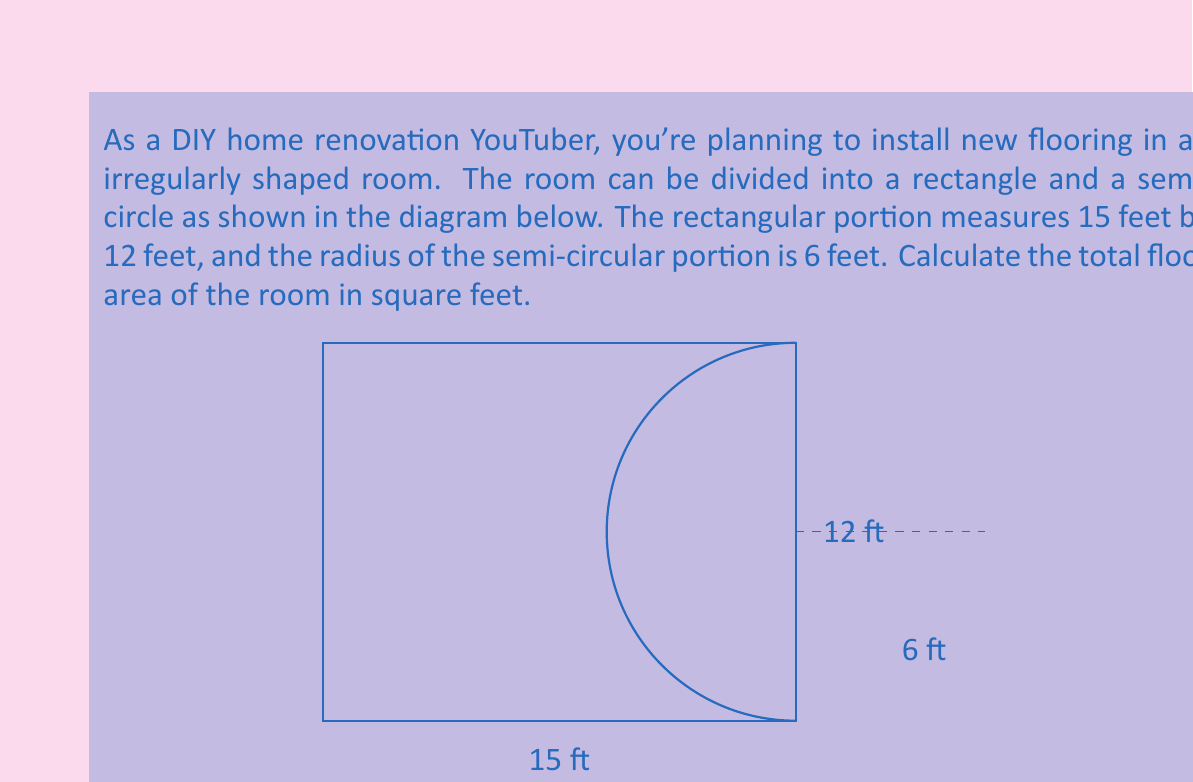Provide a solution to this math problem. To solve this problem, we need to calculate the areas of the rectangular and semi-circular portions separately and then add them together.

1. Area of the rectangular portion:
   $$A_{rectangle} = length \times width = 15 \text{ ft} \times 12 \text{ ft} = 180 \text{ sq ft}$$

2. Area of the semi-circular portion:
   The area of a full circle is $\pi r^2$, so the area of a semi-circle is half of that.
   $$A_{semi-circle} = \frac{1}{2} \pi r^2 = \frac{1}{2} \times \pi \times (6 \text{ ft})^2 = 18\pi \text{ sq ft}$$

3. Total area:
   $$A_{total} = A_{rectangle} + A_{semi-circle} = 180 \text{ sq ft} + 18\pi \text{ sq ft}$$

4. Simplify and calculate:
   $$A_{total} = 180 + 18\pi \approx 180 + 56.55 = 236.55 \text{ sq ft}$$

Rounding to the nearest square foot (which is typically sufficient for flooring calculations):
$$A_{total} \approx 237 \text{ sq ft}$$
Answer: The total floor area of the room is approximately 237 square feet. 